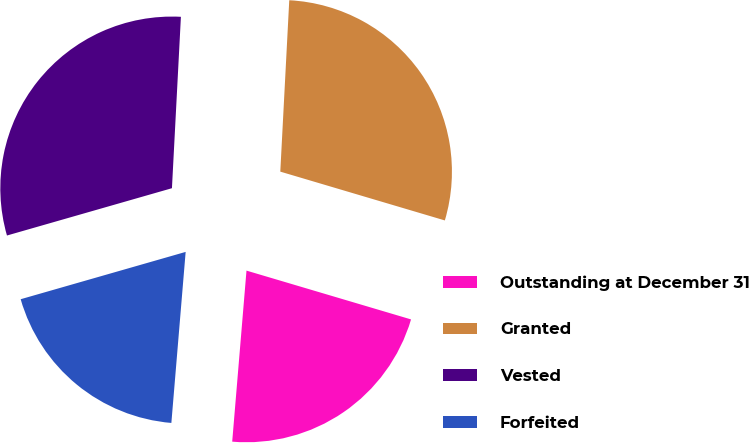<chart> <loc_0><loc_0><loc_500><loc_500><pie_chart><fcel>Outstanding at December 31<fcel>Granted<fcel>Vested<fcel>Forfeited<nl><fcel>21.74%<fcel>28.76%<fcel>30.28%<fcel>19.23%<nl></chart> 